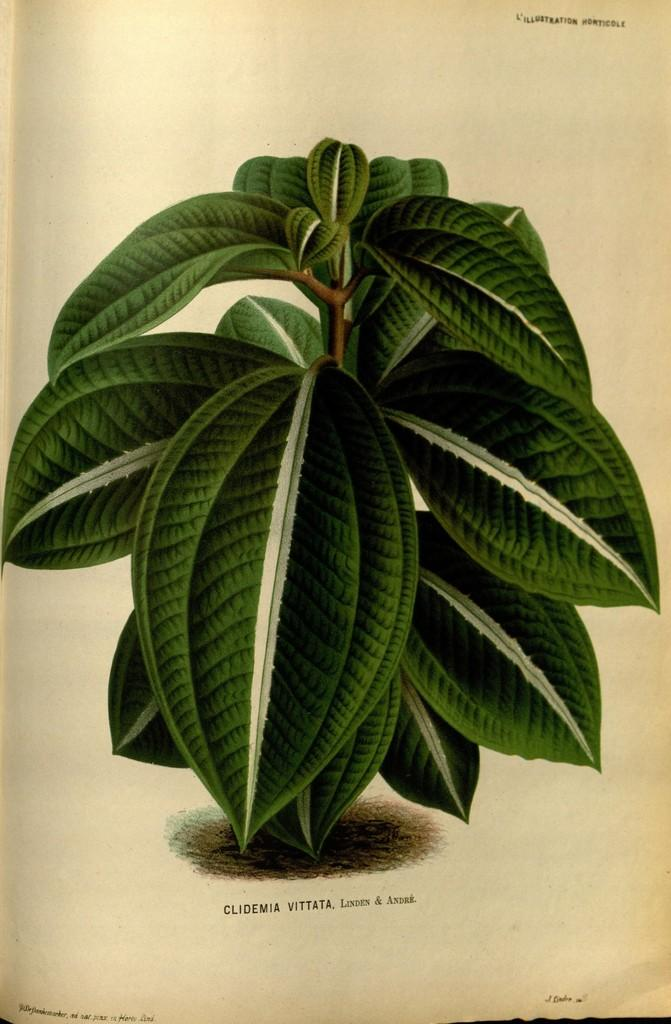What is the main subject of the paper in the image? The paper has a picture of a plant in the center. What is written or depicted below the picture on the paper? There is text below the picture on the paper. How many jellyfish are hanging from the cobweb in the image? There are no jellyfish or cobwebs present in the image. 